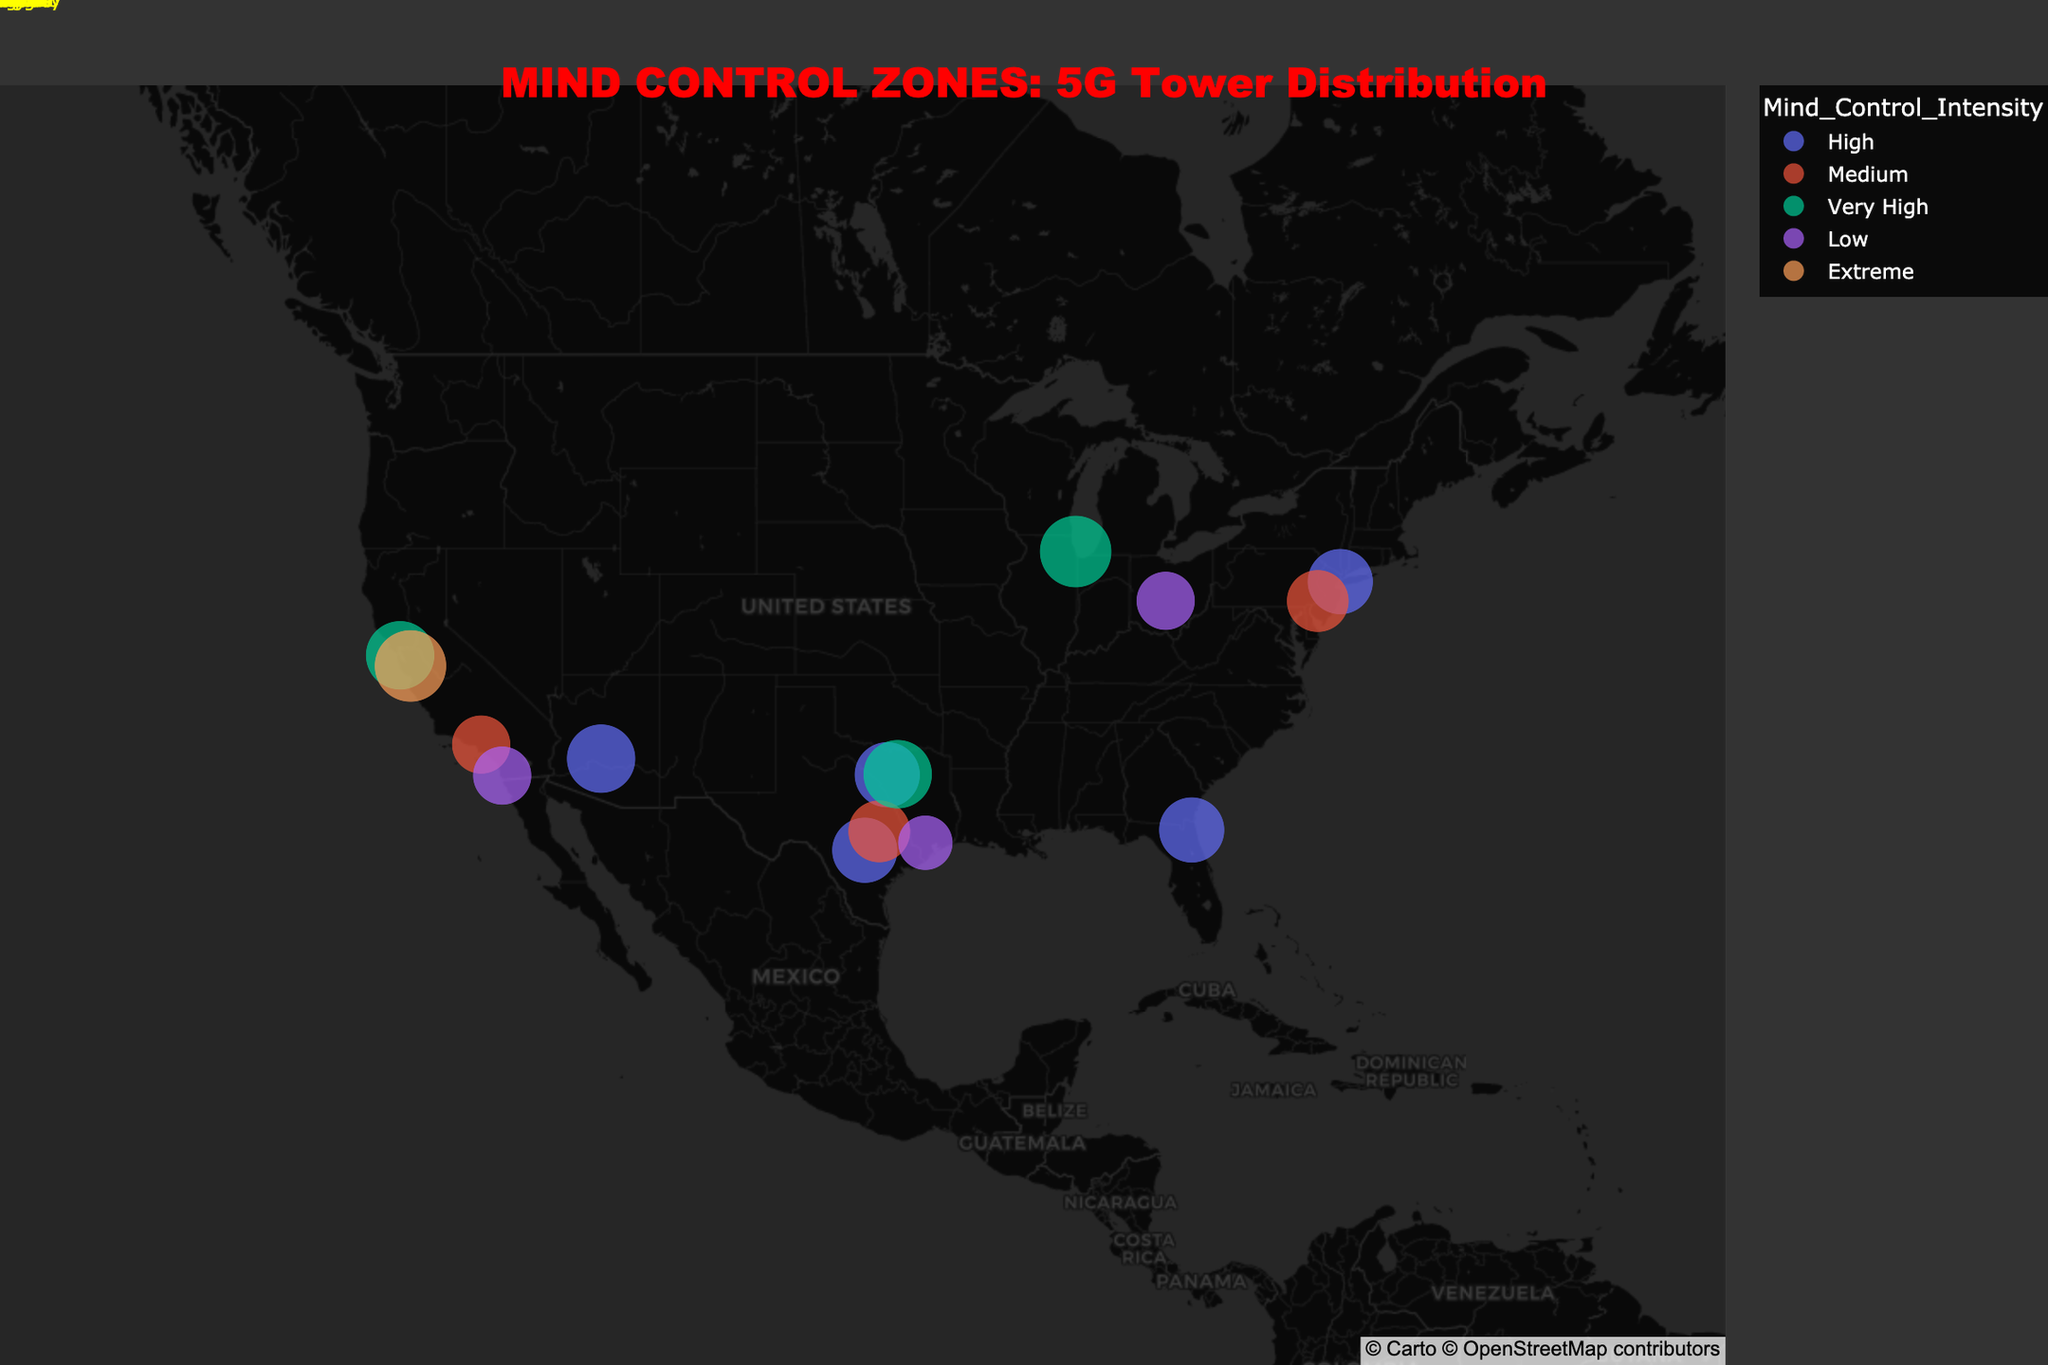How many cities have a 5G tower with 'Very High' mind control intensity? There are 4 cities with 5G towers and 'Very High' mind control intensity as indicated by their listed attributes: Chicago, Dallas, San Francisco, and New York City.
Answer: 4 Which city has the highest mind control intensity and what is its value? By looking at the mind control intensity values, the highest value is 'Extreme', and it is found in San Jose.
Answer: San Jose, Extreme Which cities have a coverage radius of 10 km? The cities with a coverage radius of 10 km, as indicated by their data points, are New York City, San Antonio, Jacksonville, and Fort Worth.
Answer: New York City, San Antonio, Jacksonville, Fort Worth Are there more cities with a 'High' mind control intensity or a 'Medium' mind control intensity? There are 6 cities with 'High' mind control intensity and 4 cities with 'Medium' mind control intensity, so there are more cities with 'High' mind control intensity.
Answer: High What is the average coverage radius of 5G towers? To find this, consider the coverage radii for all 5G towers: 10 (New York City), 12 (Chicago), 11 (Phoenix), 10 (San Antonio), 11 (Dallas), 12 (San Jose), 10 (Jacksonville), 11 (San Francisco), and 10 (Fort Worth). The sum is 97, and there are 9 towers. The average is 97 / 9 ≈ 10.78 km.
Answer: 10.78 km Which city has the smallest coverage radius and what is its value? Houston and San Antonio (4G towers) and Dallas (5G tower) each have a coverage radius of 8 km, which is the smallest value in the dataset.
Answer: Houston, 7 km Compare the mind control intensity of cities with 8 km coverage radius. Which has the highest intensity? The cities with 8 km coverage radius are Los Angeles, San Diego, and Columbus. Among them, Los Angeles and Columbus both have 'Medium' intensity, and San Diego has 'Low'. Thus, Los Angeles and Columbus have the highest intensity.
Answer: Los Angeles, Columbus What is the title of the figure? The title is written at the top of the figure: "MIND CONTROL ZONES: 5G Tower Distribution".
Answer: MIND CONTROL ZONES: 5G Tower Distribution Which cities on the map are labeled with yellow annotations? The city names in yellow annotations can be found indicated on the map, these include all cities in the dataset. You may have to look closely to identify them properly on the map.
Answer: New York City, Los Angeles, Chicago, Houston, Phoenix, Philadelphia, San Antonio, San Diego, Dallas, San Jose, Austin, Jacksonville, San Francisco, Columbus, Fort Worth 